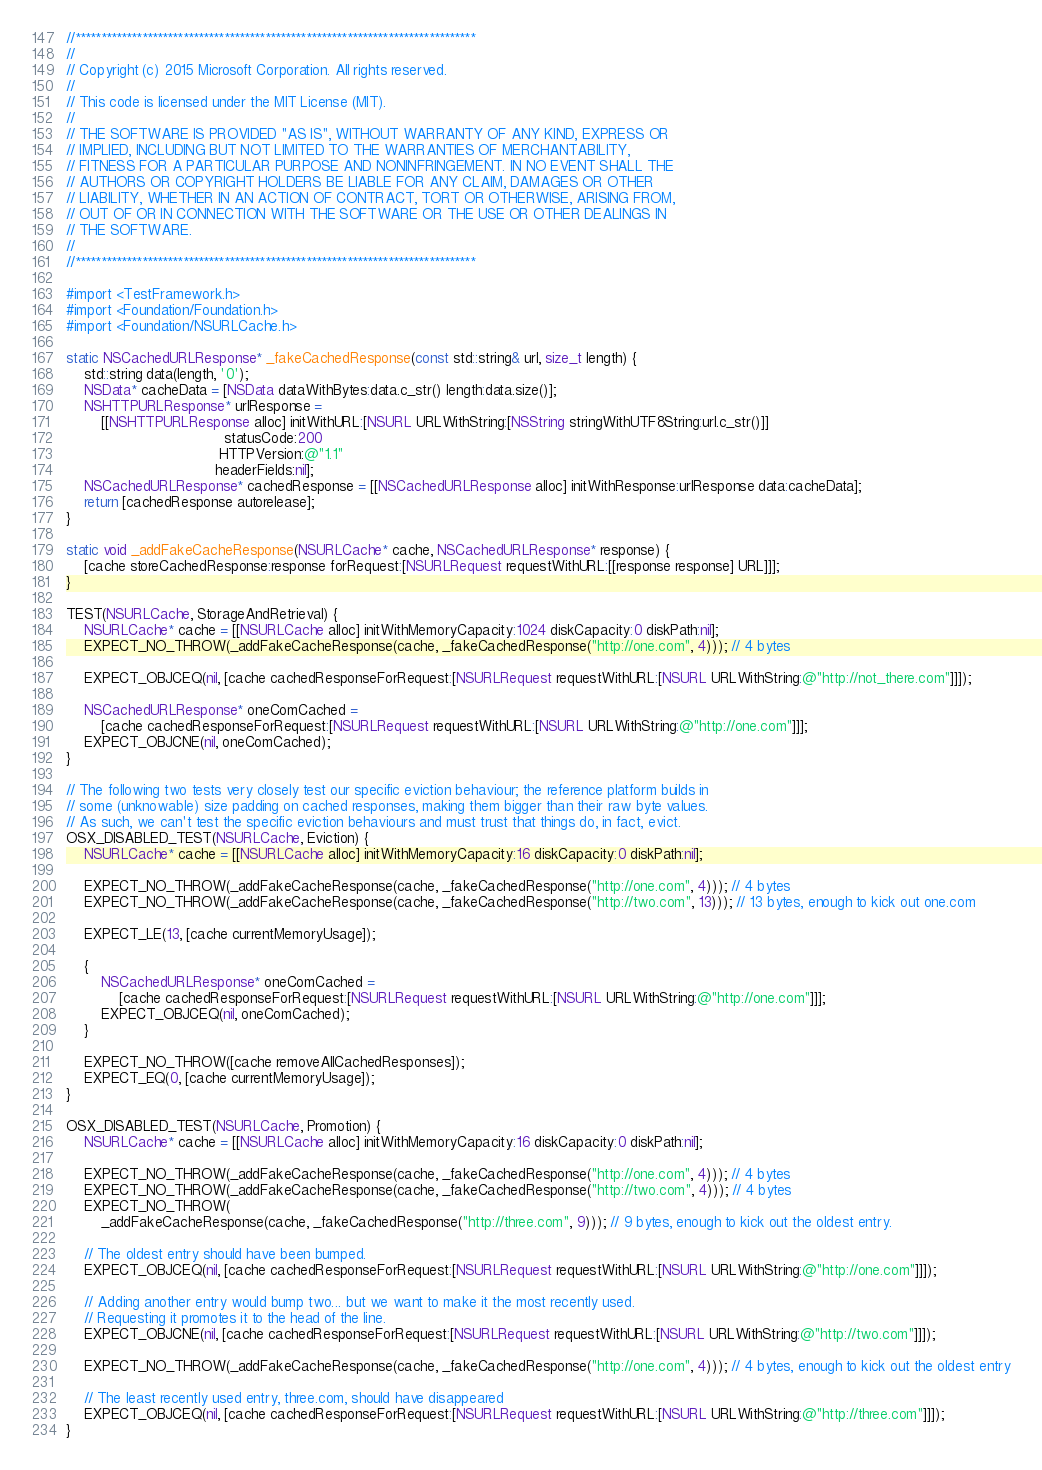<code> <loc_0><loc_0><loc_500><loc_500><_ObjectiveC_>//******************************************************************************
//
// Copyright (c) 2015 Microsoft Corporation. All rights reserved.
//
// This code is licensed under the MIT License (MIT).
//
// THE SOFTWARE IS PROVIDED "AS IS", WITHOUT WARRANTY OF ANY KIND, EXPRESS OR
// IMPLIED, INCLUDING BUT NOT LIMITED TO THE WARRANTIES OF MERCHANTABILITY,
// FITNESS FOR A PARTICULAR PURPOSE AND NONINFRINGEMENT. IN NO EVENT SHALL THE
// AUTHORS OR COPYRIGHT HOLDERS BE LIABLE FOR ANY CLAIM, DAMAGES OR OTHER
// LIABILITY, WHETHER IN AN ACTION OF CONTRACT, TORT OR OTHERWISE, ARISING FROM,
// OUT OF OR IN CONNECTION WITH THE SOFTWARE OR THE USE OR OTHER DEALINGS IN
// THE SOFTWARE.
//
//******************************************************************************

#import <TestFramework.h>
#import <Foundation/Foundation.h>
#import <Foundation/NSURLCache.h>

static NSCachedURLResponse* _fakeCachedResponse(const std::string& url, size_t length) {
    std::string data(length, '0');
    NSData* cacheData = [NSData dataWithBytes:data.c_str() length:data.size()];
    NSHTTPURLResponse* urlResponse =
        [[NSHTTPURLResponse alloc] initWithURL:[NSURL URLWithString:[NSString stringWithUTF8String:url.c_str()]]
                                    statusCode:200
                                   HTTPVersion:@"1.1"
                                  headerFields:nil];
    NSCachedURLResponse* cachedResponse = [[NSCachedURLResponse alloc] initWithResponse:urlResponse data:cacheData];
    return [cachedResponse autorelease];
}

static void _addFakeCacheResponse(NSURLCache* cache, NSCachedURLResponse* response) {
    [cache storeCachedResponse:response forRequest:[NSURLRequest requestWithURL:[[response response] URL]]];
}

TEST(NSURLCache, StorageAndRetrieval) {
    NSURLCache* cache = [[NSURLCache alloc] initWithMemoryCapacity:1024 diskCapacity:0 diskPath:nil];
    EXPECT_NO_THROW(_addFakeCacheResponse(cache, _fakeCachedResponse("http://one.com", 4))); // 4 bytes

    EXPECT_OBJCEQ(nil, [cache cachedResponseForRequest:[NSURLRequest requestWithURL:[NSURL URLWithString:@"http://not_there.com"]]]);

    NSCachedURLResponse* oneComCached =
        [cache cachedResponseForRequest:[NSURLRequest requestWithURL:[NSURL URLWithString:@"http://one.com"]]];
    EXPECT_OBJCNE(nil, oneComCached);
}

// The following two tests very closely test our specific eviction behaviour; the reference platform builds in
// some (unknowable) size padding on cached responses, making them bigger than their raw byte values.
// As such, we can't test the specific eviction behaviours and must trust that things do, in fact, evict.
OSX_DISABLED_TEST(NSURLCache, Eviction) {
    NSURLCache* cache = [[NSURLCache alloc] initWithMemoryCapacity:16 diskCapacity:0 diskPath:nil];

    EXPECT_NO_THROW(_addFakeCacheResponse(cache, _fakeCachedResponse("http://one.com", 4))); // 4 bytes
    EXPECT_NO_THROW(_addFakeCacheResponse(cache, _fakeCachedResponse("http://two.com", 13))); // 13 bytes, enough to kick out one.com

    EXPECT_LE(13, [cache currentMemoryUsage]);

    {
        NSCachedURLResponse* oneComCached =
            [cache cachedResponseForRequest:[NSURLRequest requestWithURL:[NSURL URLWithString:@"http://one.com"]]];
        EXPECT_OBJCEQ(nil, oneComCached);
    }

    EXPECT_NO_THROW([cache removeAllCachedResponses]);
    EXPECT_EQ(0, [cache currentMemoryUsage]);
}

OSX_DISABLED_TEST(NSURLCache, Promotion) {
    NSURLCache* cache = [[NSURLCache alloc] initWithMemoryCapacity:16 diskCapacity:0 diskPath:nil];

    EXPECT_NO_THROW(_addFakeCacheResponse(cache, _fakeCachedResponse("http://one.com", 4))); // 4 bytes
    EXPECT_NO_THROW(_addFakeCacheResponse(cache, _fakeCachedResponse("http://two.com", 4))); // 4 bytes
    EXPECT_NO_THROW(
        _addFakeCacheResponse(cache, _fakeCachedResponse("http://three.com", 9))); // 9 bytes, enough to kick out the oldest entry.

    // The oldest entry should have been bumped.
    EXPECT_OBJCEQ(nil, [cache cachedResponseForRequest:[NSURLRequest requestWithURL:[NSURL URLWithString:@"http://one.com"]]]);

    // Adding another entry would bump two... but we want to make it the most recently used.
    // Requesting it promotes it to the head of the line.
    EXPECT_OBJCNE(nil, [cache cachedResponseForRequest:[NSURLRequest requestWithURL:[NSURL URLWithString:@"http://two.com"]]]);

    EXPECT_NO_THROW(_addFakeCacheResponse(cache, _fakeCachedResponse("http://one.com", 4))); // 4 bytes, enough to kick out the oldest entry

    // The least recently used entry, three.com, should have disappeared
    EXPECT_OBJCEQ(nil, [cache cachedResponseForRequest:[NSURLRequest requestWithURL:[NSURL URLWithString:@"http://three.com"]]]);
}
</code> 